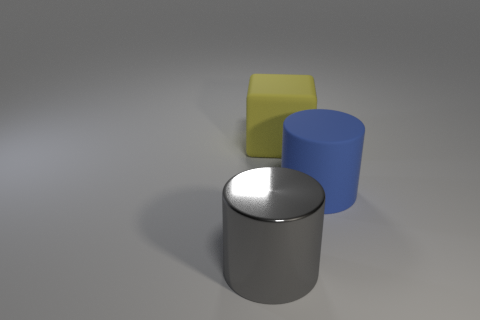What is the material of the big thing that is left of the matte thing behind the cylinder that is to the right of the metallic cylinder?
Your response must be concise. Metal. Is the number of large gray metal cylinders that are right of the blue rubber cylinder the same as the number of large blue rubber cubes?
Provide a short and direct response. Yes. What number of things are either gray metallic cylinders or yellow cubes?
Keep it short and to the point. 2. What shape is the other big thing that is made of the same material as the large blue object?
Offer a very short reply. Cube. What size is the cylinder behind the gray object that is in front of the big matte cube?
Provide a succinct answer. Large. How many small objects are either yellow matte cubes or blue matte cylinders?
Make the answer very short. 0. How many other things are there of the same color as the large metal cylinder?
Offer a very short reply. 0. Does the thing that is in front of the large blue matte object have the same size as the matte thing behind the blue cylinder?
Your answer should be very brief. Yes. Is the gray thing made of the same material as the cylinder that is on the right side of the big gray metal object?
Your response must be concise. No. Are there more large blue cylinders to the right of the large blue rubber cylinder than big rubber objects in front of the metal object?
Keep it short and to the point. No. 